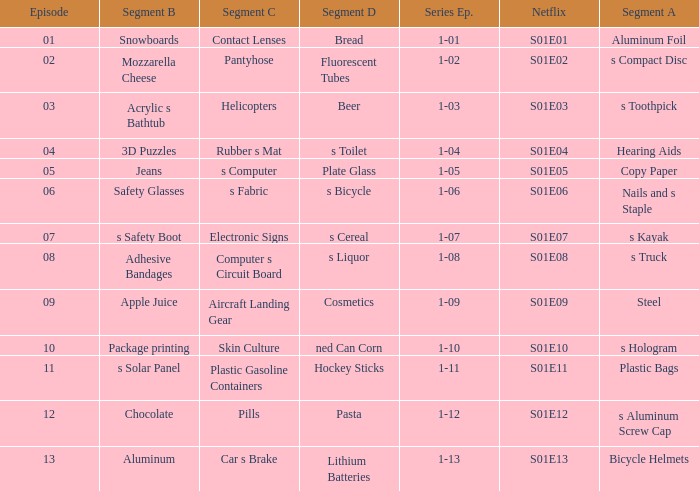What is the segment A name, having a Netflix of s01e12? S aluminum screw cap. 